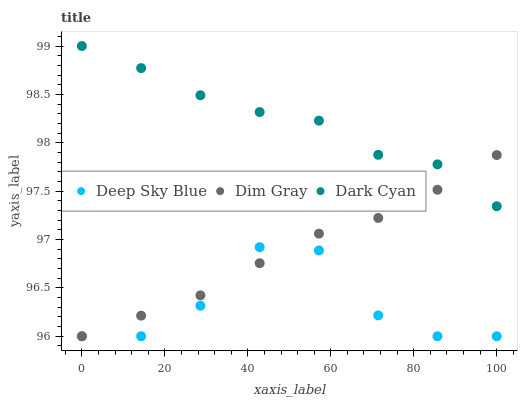Does Deep Sky Blue have the minimum area under the curve?
Answer yes or no. Yes. Does Dark Cyan have the maximum area under the curve?
Answer yes or no. Yes. Does Dim Gray have the minimum area under the curve?
Answer yes or no. No. Does Dim Gray have the maximum area under the curve?
Answer yes or no. No. Is Dim Gray the smoothest?
Answer yes or no. Yes. Is Deep Sky Blue the roughest?
Answer yes or no. Yes. Is Deep Sky Blue the smoothest?
Answer yes or no. No. Is Dim Gray the roughest?
Answer yes or no. No. Does Dim Gray have the lowest value?
Answer yes or no. Yes. Does Dark Cyan have the highest value?
Answer yes or no. Yes. Does Dim Gray have the highest value?
Answer yes or no. No. Is Deep Sky Blue less than Dark Cyan?
Answer yes or no. Yes. Is Dark Cyan greater than Deep Sky Blue?
Answer yes or no. Yes. Does Dim Gray intersect Dark Cyan?
Answer yes or no. Yes. Is Dim Gray less than Dark Cyan?
Answer yes or no. No. Is Dim Gray greater than Dark Cyan?
Answer yes or no. No. Does Deep Sky Blue intersect Dark Cyan?
Answer yes or no. No. 